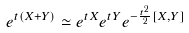Convert formula to latex. <formula><loc_0><loc_0><loc_500><loc_500>e ^ { t ( X + Y ) } \simeq e ^ { t X } e ^ { t Y } e ^ { - \frac { t ^ { 2 } } { 2 } [ X , Y ] }</formula> 